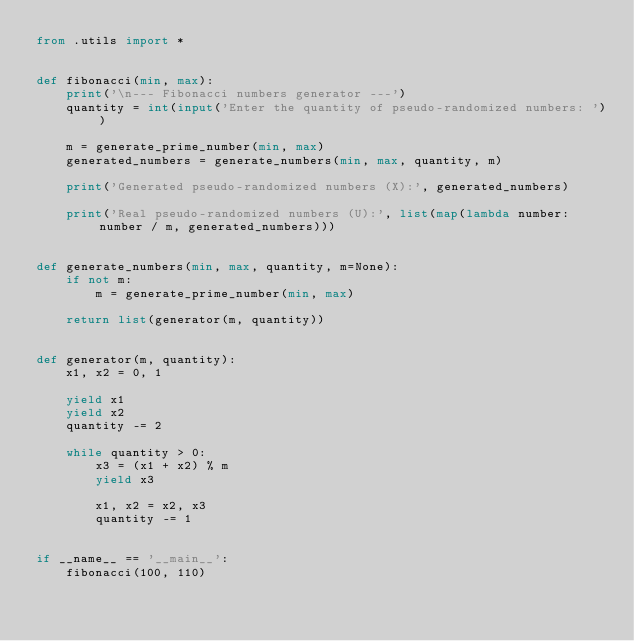Convert code to text. <code><loc_0><loc_0><loc_500><loc_500><_Python_>from .utils import *


def fibonacci(min, max):
    print('\n--- Fibonacci numbers generator ---')
    quantity = int(input('Enter the quantity of pseudo-randomized numbers: '))

    m = generate_prime_number(min, max)
    generated_numbers = generate_numbers(min, max, quantity, m)

    print('Generated pseudo-randomized numbers (X):', generated_numbers)

    print('Real pseudo-randomized numbers (U):', list(map(lambda number: number / m, generated_numbers)))


def generate_numbers(min, max, quantity, m=None):
    if not m:
        m = generate_prime_number(min, max)

    return list(generator(m, quantity))


def generator(m, quantity):
    x1, x2 = 0, 1

    yield x1
    yield x2
    quantity -= 2

    while quantity > 0:
        x3 = (x1 + x2) % m
        yield x3

        x1, x2 = x2, x3
        quantity -= 1


if __name__ == '__main__':
    fibonacci(100, 110)
</code> 